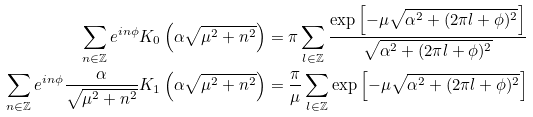<formula> <loc_0><loc_0><loc_500><loc_500>\sum _ { n \in \mathbb { Z } } e ^ { i n \phi } K _ { 0 } \left ( \alpha \sqrt { \mu ^ { 2 } + n ^ { 2 } } \right ) & = \pi \sum _ { l \in \mathbb { Z } } \frac { \exp \left [ - \mu \sqrt { \alpha ^ { 2 } + ( 2 \pi l + \phi ) ^ { 2 } } \right ] } { \sqrt { \alpha ^ { 2 } + ( 2 \pi l + \phi ) ^ { 2 } } } \\ \sum _ { n \in \mathbb { Z } } e ^ { i n \phi } \frac { \alpha } { \sqrt { \mu ^ { 2 } + n ^ { 2 } } } K _ { 1 } \left ( \alpha \sqrt { \mu ^ { 2 } + n ^ { 2 } } \right ) & = \frac { \pi } { \mu } \sum _ { l \in \mathbb { Z } } \exp \left [ - \mu \sqrt { \alpha ^ { 2 } + ( 2 \pi l + \phi ) ^ { 2 } } \right ]</formula> 